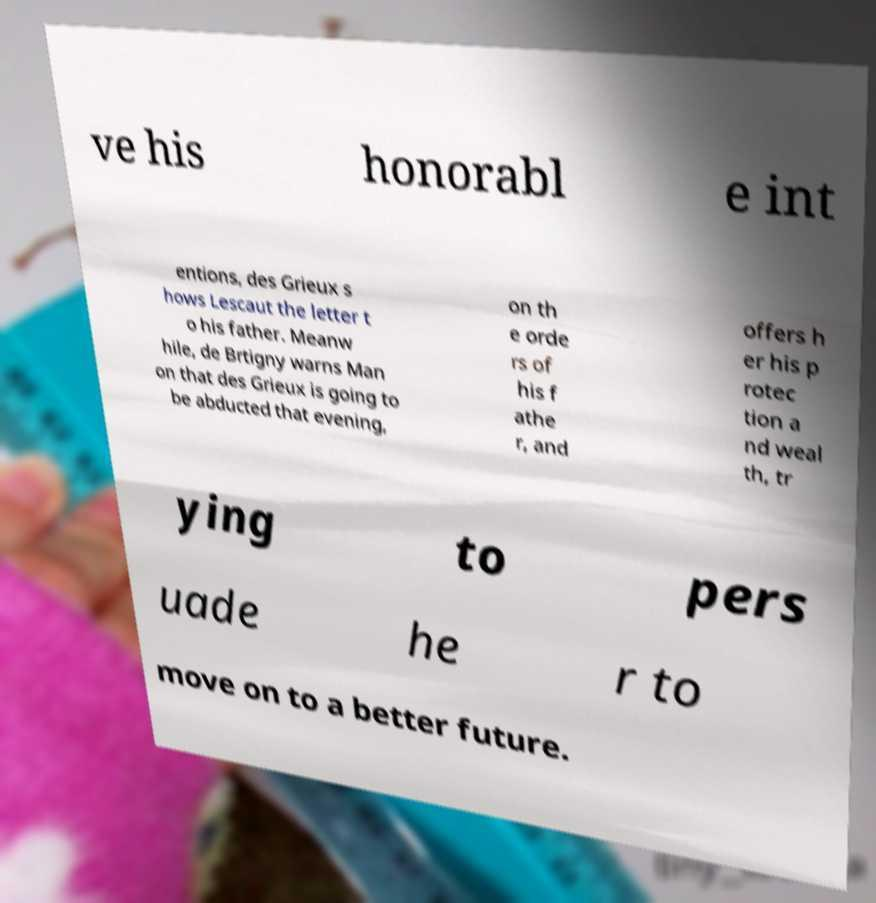Please read and relay the text visible in this image. What does it say? ve his honorabl e int entions, des Grieux s hows Lescaut the letter t o his father. Meanw hile, de Brtigny warns Man on that des Grieux is going to be abducted that evening, on th e orde rs of his f athe r, and offers h er his p rotec tion a nd weal th, tr ying to pers uade he r to move on to a better future. 